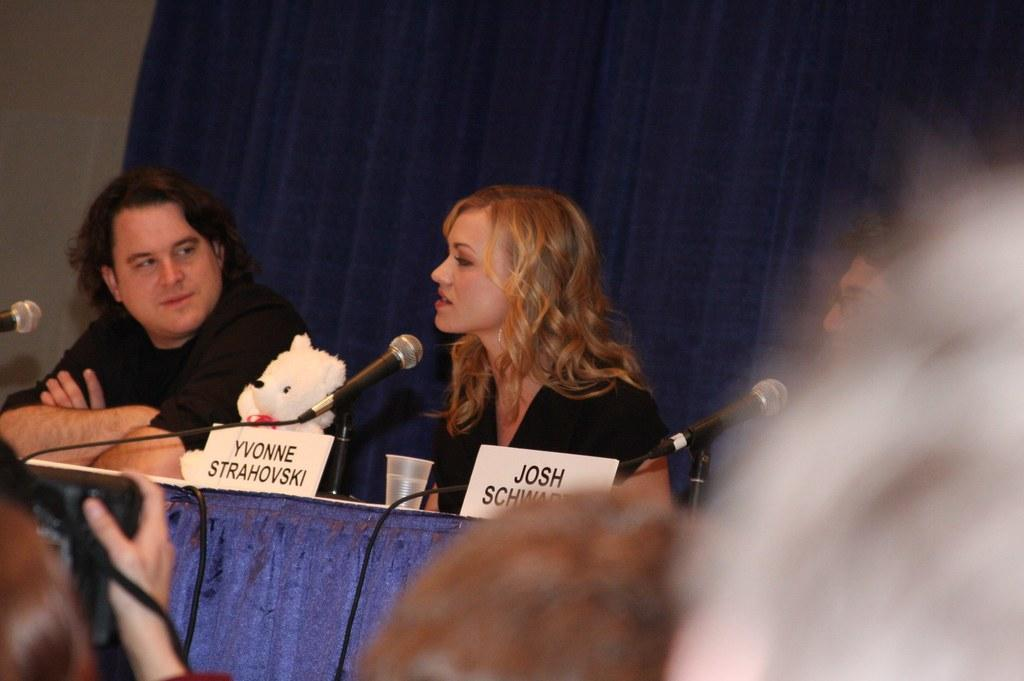What type of furniture is present in the image? There is a table in the image. What objects are on the table? There are black color microphones on the table. What can be seen in terms of people in the image? There are people sitting in the image. What color is the curtain in the background of the image? There is a blue color curtain in the background of the image. How many cherries are on the table in the image? There are no cherries present in the image. What is the limit of the frog's jumping ability in the image? There is no frog present in the image, so its jumping ability cannot be determined. 